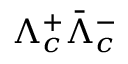Convert formula to latex. <formula><loc_0><loc_0><loc_500><loc_500>\Lambda _ { c } ^ { + } \bar { \Lambda _ { c } ^ { - }</formula> 